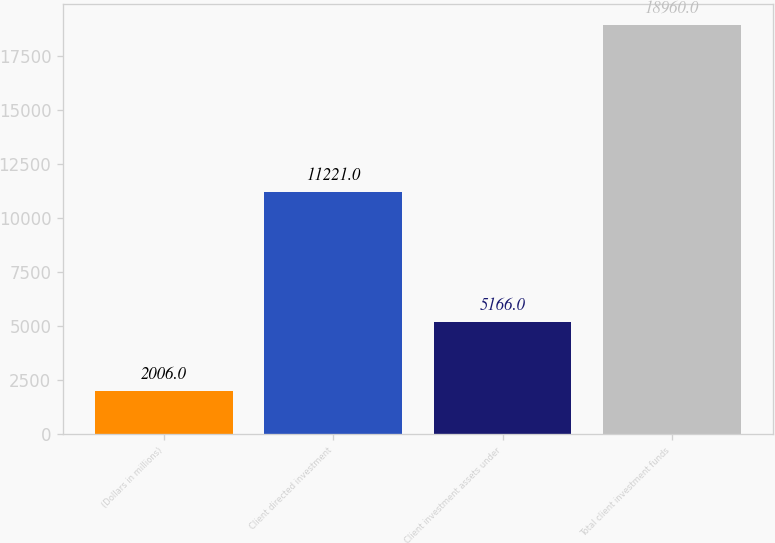Convert chart to OTSL. <chart><loc_0><loc_0><loc_500><loc_500><bar_chart><fcel>(Dollars in millions)<fcel>Client directed investment<fcel>Client investment assets under<fcel>Total client investment funds<nl><fcel>2006<fcel>11221<fcel>5166<fcel>18960<nl></chart> 